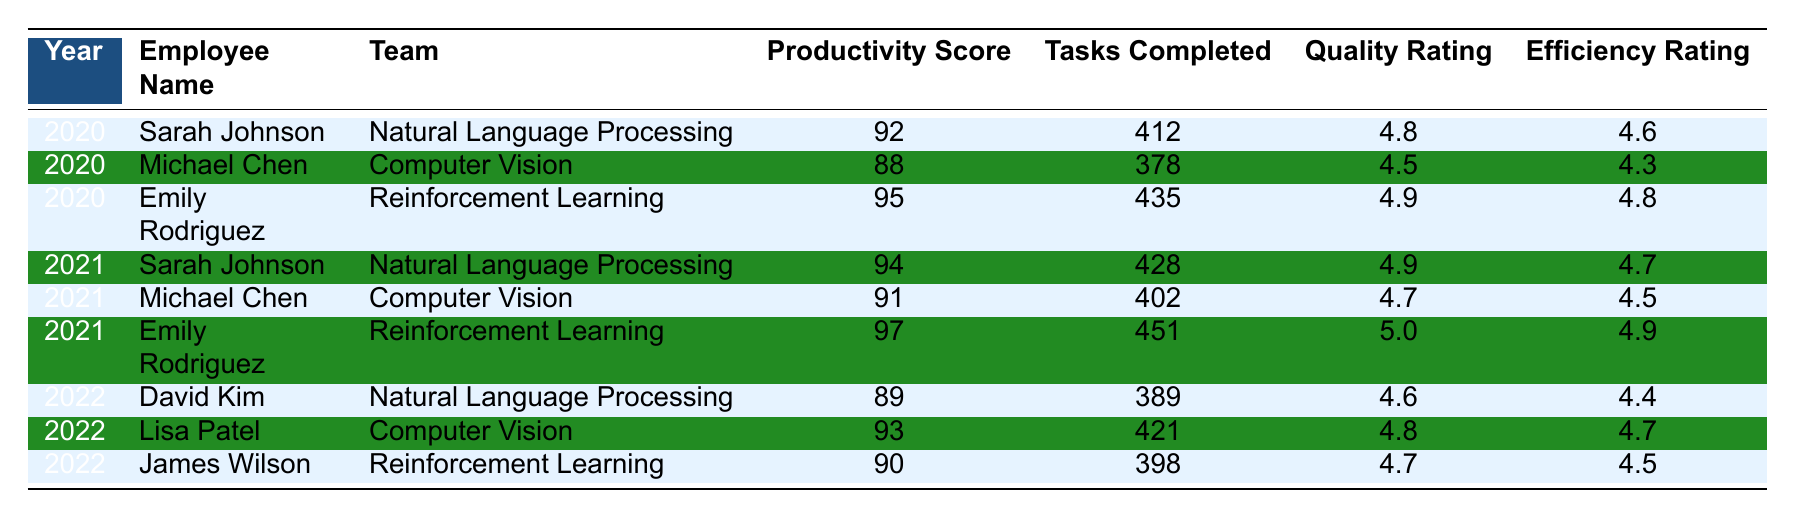What is the productivity score of Emily Rodriguez in 2021? In the table, look for Emily Rodriguez and the year 2021. She is listed with a productivity score of 97.
Answer: 97 Which team did Sarah Johnson work in during 2020? Checking the table for Sarah Johnson's entry in 2020, she is associated with the Natural Language Processing team.
Answer: Natural Language Processing Who completed the most tasks in 2021? Review the tasks completed column for the 2021 entries. Emily Rodriguez completed 451 tasks, which is the highest.
Answer: Emily Rodriguez What is the average quality rating of employees in the Computer Vision team across all years? The quality ratings for the Computer Vision team are 4.5 (Michael Chen, 2020), 4.7 (Michael Chen, 2021), and 4.8 (Lisa Patel, 2022). Adding these gives 4.5 + 4.7 + 4.8 = 14.0, then divide by 3, which results in an average of 4.67.
Answer: 4.67 Did any employee achieve a productivity score of 95 or higher in 2020? Check the productivity scores for the year 2020. Emily Rodriguez has a score of 95, which meets the criteria.
Answer: Yes Which year did David Kim achieve the lowest productivity score? Looking at David Kim's entries, he has a productivity score of 89 in 2022 and does not appear in 2020 or 2021, thus this is his lowest score.
Answer: 2022 Among all employees, who had the highest efficiency rating in 2021? Investigate the efficiency ratings for the year 2021. Emily Rodriguez has the highest efficiency rating of 4.9.
Answer: Emily Rodriguez In terms of average productivity scores, how does the 2021 cohort compare with the 2020 cohort? Calculate the averages: 2020 scores are 92, 88, 95 (average = (92 + 88 + 95) / 3 = 91.67) and 2021 scores are 94, 91, 97 (average = (94 + 91 + 97) / 3 = 94.0). The 2021 cohort has a higher average.
Answer: 2021 is higher Is there an employee who scored the same productivity score in different years? Reviewing the data shows that Michael Chen scored 88 in 2020 and 91 in 2021, but there are no duplicate scores in different years for any employee.
Answer: No What was the total number of tasks completed by all employees in the year 2022? Add the tasks completed by each employee in 2022: 389 (David Kim) + 421 (Lisa Patel) + 398 (James Wilson) = 1208.
Answer: 1208 